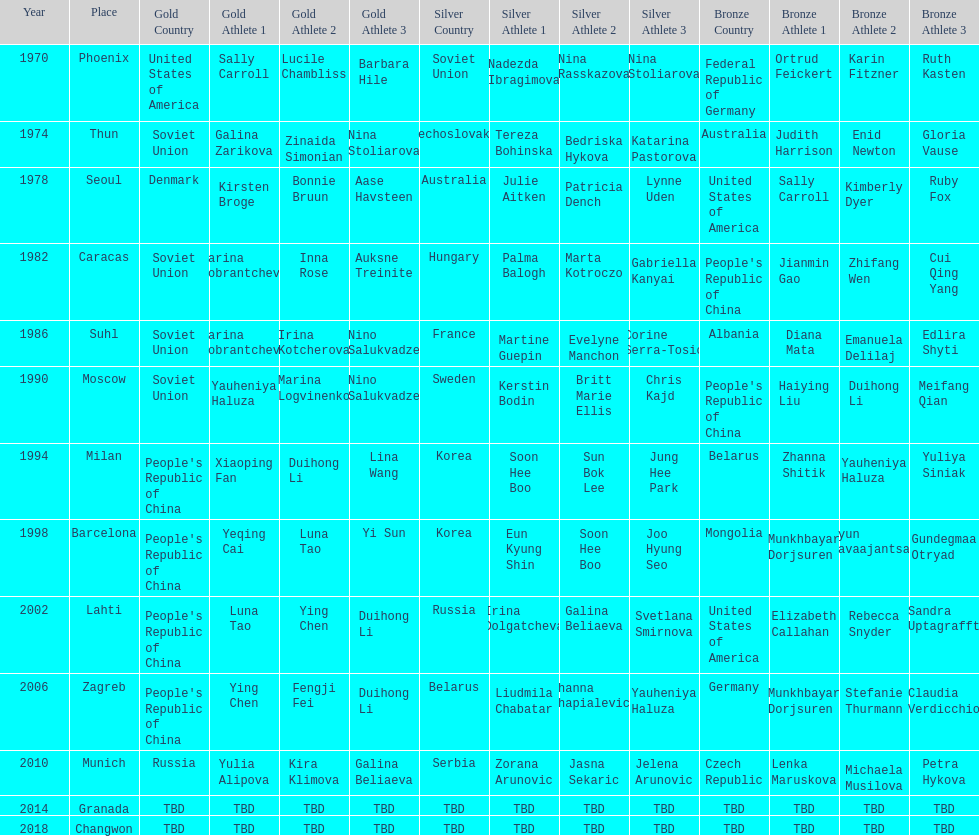What is the first place listed in this chart? Phoenix. 